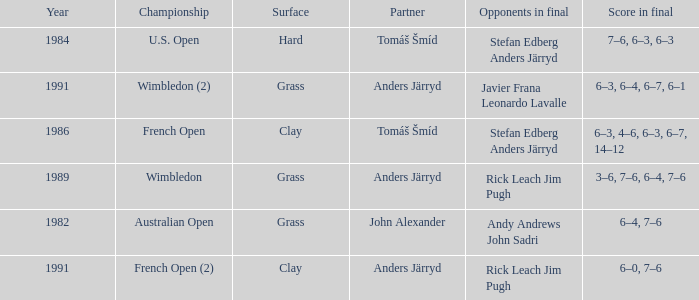What was the final score in 1986? 6–3, 4–6, 6–3, 6–7, 14–12. 